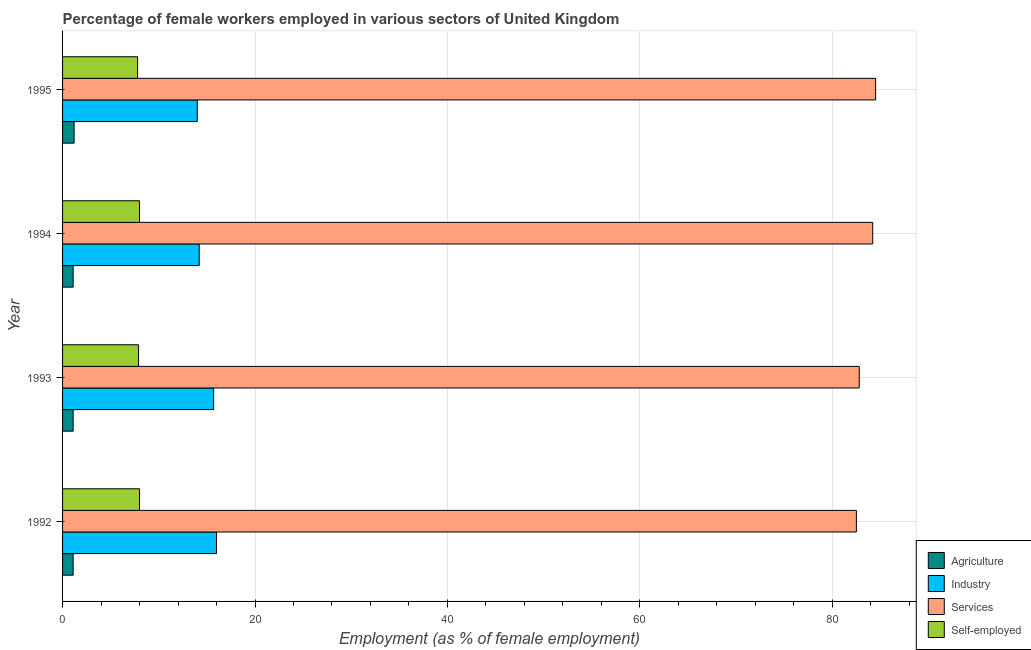How many different coloured bars are there?
Provide a succinct answer. 4. How many bars are there on the 1st tick from the bottom?
Make the answer very short. 4. What is the label of the 1st group of bars from the top?
Keep it short and to the point. 1995. In how many cases, is the number of bars for a given year not equal to the number of legend labels?
Keep it short and to the point. 0. What is the percentage of female workers in agriculture in 1994?
Provide a succinct answer. 1.1. Across all years, what is the minimum percentage of self employed female workers?
Offer a very short reply. 7.8. In which year was the percentage of female workers in services maximum?
Provide a succinct answer. 1995. In which year was the percentage of female workers in industry minimum?
Your answer should be very brief. 1995. What is the total percentage of female workers in services in the graph?
Give a very brief answer. 334. What is the difference between the percentage of female workers in services in 1993 and that in 1994?
Provide a short and direct response. -1.4. What is the difference between the percentage of female workers in agriculture in 1992 and the percentage of self employed female workers in 1995?
Provide a succinct answer. -6.7. What is the average percentage of female workers in industry per year?
Offer a very short reply. 14.97. In the year 1994, what is the difference between the percentage of female workers in industry and percentage of self employed female workers?
Offer a terse response. 6.2. In how many years, is the percentage of female workers in services greater than 24 %?
Your answer should be very brief. 4. Is the percentage of self employed female workers in 1993 less than that in 1995?
Provide a succinct answer. No. What is the difference between the highest and the second highest percentage of female workers in industry?
Make the answer very short. 0.3. What is the difference between the highest and the lowest percentage of self employed female workers?
Your answer should be compact. 0.2. In how many years, is the percentage of female workers in services greater than the average percentage of female workers in services taken over all years?
Your response must be concise. 2. Is it the case that in every year, the sum of the percentage of female workers in services and percentage of female workers in industry is greater than the sum of percentage of self employed female workers and percentage of female workers in agriculture?
Give a very brief answer. Yes. What does the 1st bar from the top in 1993 represents?
Ensure brevity in your answer.  Self-employed. What does the 4th bar from the bottom in 1993 represents?
Offer a very short reply. Self-employed. How many bars are there?
Provide a short and direct response. 16. Are all the bars in the graph horizontal?
Make the answer very short. Yes. How many legend labels are there?
Keep it short and to the point. 4. What is the title of the graph?
Keep it short and to the point. Percentage of female workers employed in various sectors of United Kingdom. Does "Trade" appear as one of the legend labels in the graph?
Offer a very short reply. No. What is the label or title of the X-axis?
Offer a very short reply. Employment (as % of female employment). What is the Employment (as % of female employment) of Agriculture in 1992?
Your response must be concise. 1.1. What is the Employment (as % of female employment) in Services in 1992?
Give a very brief answer. 82.5. What is the Employment (as % of female employment) in Self-employed in 1992?
Give a very brief answer. 8. What is the Employment (as % of female employment) in Agriculture in 1993?
Keep it short and to the point. 1.1. What is the Employment (as % of female employment) of Industry in 1993?
Offer a very short reply. 15.7. What is the Employment (as % of female employment) in Services in 1993?
Offer a terse response. 82.8. What is the Employment (as % of female employment) in Self-employed in 1993?
Make the answer very short. 7.9. What is the Employment (as % of female employment) in Agriculture in 1994?
Offer a very short reply. 1.1. What is the Employment (as % of female employment) in Industry in 1994?
Keep it short and to the point. 14.2. What is the Employment (as % of female employment) of Services in 1994?
Provide a short and direct response. 84.2. What is the Employment (as % of female employment) in Agriculture in 1995?
Your answer should be compact. 1.2. What is the Employment (as % of female employment) in Industry in 1995?
Your response must be concise. 14. What is the Employment (as % of female employment) of Services in 1995?
Give a very brief answer. 84.5. What is the Employment (as % of female employment) of Self-employed in 1995?
Offer a very short reply. 7.8. Across all years, what is the maximum Employment (as % of female employment) in Agriculture?
Your response must be concise. 1.2. Across all years, what is the maximum Employment (as % of female employment) in Industry?
Give a very brief answer. 16. Across all years, what is the maximum Employment (as % of female employment) of Services?
Provide a short and direct response. 84.5. Across all years, what is the maximum Employment (as % of female employment) in Self-employed?
Ensure brevity in your answer.  8. Across all years, what is the minimum Employment (as % of female employment) of Agriculture?
Ensure brevity in your answer.  1.1. Across all years, what is the minimum Employment (as % of female employment) of Industry?
Ensure brevity in your answer.  14. Across all years, what is the minimum Employment (as % of female employment) of Services?
Keep it short and to the point. 82.5. Across all years, what is the minimum Employment (as % of female employment) in Self-employed?
Offer a very short reply. 7.8. What is the total Employment (as % of female employment) of Agriculture in the graph?
Your answer should be compact. 4.5. What is the total Employment (as % of female employment) in Industry in the graph?
Make the answer very short. 59.9. What is the total Employment (as % of female employment) of Services in the graph?
Offer a very short reply. 334. What is the total Employment (as % of female employment) in Self-employed in the graph?
Make the answer very short. 31.7. What is the difference between the Employment (as % of female employment) in Agriculture in 1992 and that in 1994?
Keep it short and to the point. 0. What is the difference between the Employment (as % of female employment) of Industry in 1992 and that in 1994?
Offer a terse response. 1.8. What is the difference between the Employment (as % of female employment) of Services in 1992 and that in 1994?
Make the answer very short. -1.7. What is the difference between the Employment (as % of female employment) of Self-employed in 1992 and that in 1994?
Provide a succinct answer. 0. What is the difference between the Employment (as % of female employment) of Industry in 1992 and that in 1995?
Your answer should be very brief. 2. What is the difference between the Employment (as % of female employment) in Services in 1992 and that in 1995?
Your answer should be very brief. -2. What is the difference between the Employment (as % of female employment) in Agriculture in 1993 and that in 1994?
Your answer should be compact. 0. What is the difference between the Employment (as % of female employment) in Industry in 1993 and that in 1994?
Your answer should be very brief. 1.5. What is the difference between the Employment (as % of female employment) in Self-employed in 1993 and that in 1994?
Make the answer very short. -0.1. What is the difference between the Employment (as % of female employment) in Agriculture in 1993 and that in 1995?
Provide a succinct answer. -0.1. What is the difference between the Employment (as % of female employment) of Self-employed in 1993 and that in 1995?
Keep it short and to the point. 0.1. What is the difference between the Employment (as % of female employment) in Agriculture in 1992 and the Employment (as % of female employment) in Industry in 1993?
Ensure brevity in your answer.  -14.6. What is the difference between the Employment (as % of female employment) in Agriculture in 1992 and the Employment (as % of female employment) in Services in 1993?
Provide a short and direct response. -81.7. What is the difference between the Employment (as % of female employment) in Industry in 1992 and the Employment (as % of female employment) in Services in 1993?
Provide a short and direct response. -66.8. What is the difference between the Employment (as % of female employment) in Services in 1992 and the Employment (as % of female employment) in Self-employed in 1993?
Give a very brief answer. 74.6. What is the difference between the Employment (as % of female employment) of Agriculture in 1992 and the Employment (as % of female employment) of Industry in 1994?
Offer a terse response. -13.1. What is the difference between the Employment (as % of female employment) in Agriculture in 1992 and the Employment (as % of female employment) in Services in 1994?
Make the answer very short. -83.1. What is the difference between the Employment (as % of female employment) in Industry in 1992 and the Employment (as % of female employment) in Services in 1994?
Offer a very short reply. -68.2. What is the difference between the Employment (as % of female employment) of Services in 1992 and the Employment (as % of female employment) of Self-employed in 1994?
Your response must be concise. 74.5. What is the difference between the Employment (as % of female employment) of Agriculture in 1992 and the Employment (as % of female employment) of Services in 1995?
Provide a succinct answer. -83.4. What is the difference between the Employment (as % of female employment) of Agriculture in 1992 and the Employment (as % of female employment) of Self-employed in 1995?
Offer a terse response. -6.7. What is the difference between the Employment (as % of female employment) of Industry in 1992 and the Employment (as % of female employment) of Services in 1995?
Your answer should be very brief. -68.5. What is the difference between the Employment (as % of female employment) of Services in 1992 and the Employment (as % of female employment) of Self-employed in 1995?
Your answer should be very brief. 74.7. What is the difference between the Employment (as % of female employment) in Agriculture in 1993 and the Employment (as % of female employment) in Services in 1994?
Keep it short and to the point. -83.1. What is the difference between the Employment (as % of female employment) in Industry in 1993 and the Employment (as % of female employment) in Services in 1994?
Your response must be concise. -68.5. What is the difference between the Employment (as % of female employment) in Industry in 1993 and the Employment (as % of female employment) in Self-employed in 1994?
Provide a short and direct response. 7.7. What is the difference between the Employment (as % of female employment) of Services in 1993 and the Employment (as % of female employment) of Self-employed in 1994?
Your answer should be compact. 74.8. What is the difference between the Employment (as % of female employment) in Agriculture in 1993 and the Employment (as % of female employment) in Industry in 1995?
Give a very brief answer. -12.9. What is the difference between the Employment (as % of female employment) in Agriculture in 1993 and the Employment (as % of female employment) in Services in 1995?
Offer a very short reply. -83.4. What is the difference between the Employment (as % of female employment) in Industry in 1993 and the Employment (as % of female employment) in Services in 1995?
Keep it short and to the point. -68.8. What is the difference between the Employment (as % of female employment) in Services in 1993 and the Employment (as % of female employment) in Self-employed in 1995?
Offer a terse response. 75. What is the difference between the Employment (as % of female employment) of Agriculture in 1994 and the Employment (as % of female employment) of Industry in 1995?
Provide a succinct answer. -12.9. What is the difference between the Employment (as % of female employment) of Agriculture in 1994 and the Employment (as % of female employment) of Services in 1995?
Your answer should be very brief. -83.4. What is the difference between the Employment (as % of female employment) in Industry in 1994 and the Employment (as % of female employment) in Services in 1995?
Offer a terse response. -70.3. What is the difference between the Employment (as % of female employment) in Services in 1994 and the Employment (as % of female employment) in Self-employed in 1995?
Keep it short and to the point. 76.4. What is the average Employment (as % of female employment) in Industry per year?
Your answer should be compact. 14.97. What is the average Employment (as % of female employment) of Services per year?
Your answer should be very brief. 83.5. What is the average Employment (as % of female employment) in Self-employed per year?
Provide a short and direct response. 7.92. In the year 1992, what is the difference between the Employment (as % of female employment) in Agriculture and Employment (as % of female employment) in Industry?
Offer a terse response. -14.9. In the year 1992, what is the difference between the Employment (as % of female employment) in Agriculture and Employment (as % of female employment) in Services?
Offer a terse response. -81.4. In the year 1992, what is the difference between the Employment (as % of female employment) of Industry and Employment (as % of female employment) of Services?
Offer a very short reply. -66.5. In the year 1992, what is the difference between the Employment (as % of female employment) of Services and Employment (as % of female employment) of Self-employed?
Keep it short and to the point. 74.5. In the year 1993, what is the difference between the Employment (as % of female employment) of Agriculture and Employment (as % of female employment) of Industry?
Offer a very short reply. -14.6. In the year 1993, what is the difference between the Employment (as % of female employment) in Agriculture and Employment (as % of female employment) in Services?
Ensure brevity in your answer.  -81.7. In the year 1993, what is the difference between the Employment (as % of female employment) of Industry and Employment (as % of female employment) of Services?
Offer a terse response. -67.1. In the year 1993, what is the difference between the Employment (as % of female employment) in Industry and Employment (as % of female employment) in Self-employed?
Offer a terse response. 7.8. In the year 1993, what is the difference between the Employment (as % of female employment) in Services and Employment (as % of female employment) in Self-employed?
Offer a terse response. 74.9. In the year 1994, what is the difference between the Employment (as % of female employment) in Agriculture and Employment (as % of female employment) in Services?
Give a very brief answer. -83.1. In the year 1994, what is the difference between the Employment (as % of female employment) of Industry and Employment (as % of female employment) of Services?
Provide a succinct answer. -70. In the year 1994, what is the difference between the Employment (as % of female employment) of Services and Employment (as % of female employment) of Self-employed?
Keep it short and to the point. 76.2. In the year 1995, what is the difference between the Employment (as % of female employment) in Agriculture and Employment (as % of female employment) in Industry?
Your answer should be very brief. -12.8. In the year 1995, what is the difference between the Employment (as % of female employment) of Agriculture and Employment (as % of female employment) of Services?
Your answer should be compact. -83.3. In the year 1995, what is the difference between the Employment (as % of female employment) in Industry and Employment (as % of female employment) in Services?
Make the answer very short. -70.5. In the year 1995, what is the difference between the Employment (as % of female employment) of Services and Employment (as % of female employment) of Self-employed?
Make the answer very short. 76.7. What is the ratio of the Employment (as % of female employment) of Agriculture in 1992 to that in 1993?
Your answer should be compact. 1. What is the ratio of the Employment (as % of female employment) in Industry in 1992 to that in 1993?
Make the answer very short. 1.02. What is the ratio of the Employment (as % of female employment) of Services in 1992 to that in 1993?
Make the answer very short. 1. What is the ratio of the Employment (as % of female employment) of Self-employed in 1992 to that in 1993?
Provide a succinct answer. 1.01. What is the ratio of the Employment (as % of female employment) in Agriculture in 1992 to that in 1994?
Make the answer very short. 1. What is the ratio of the Employment (as % of female employment) in Industry in 1992 to that in 1994?
Ensure brevity in your answer.  1.13. What is the ratio of the Employment (as % of female employment) of Services in 1992 to that in 1994?
Keep it short and to the point. 0.98. What is the ratio of the Employment (as % of female employment) in Services in 1992 to that in 1995?
Your answer should be compact. 0.98. What is the ratio of the Employment (as % of female employment) in Self-employed in 1992 to that in 1995?
Make the answer very short. 1.03. What is the ratio of the Employment (as % of female employment) of Agriculture in 1993 to that in 1994?
Make the answer very short. 1. What is the ratio of the Employment (as % of female employment) of Industry in 1993 to that in 1994?
Your answer should be compact. 1.11. What is the ratio of the Employment (as % of female employment) in Services in 1993 to that in 1994?
Keep it short and to the point. 0.98. What is the ratio of the Employment (as % of female employment) of Self-employed in 1993 to that in 1994?
Your response must be concise. 0.99. What is the ratio of the Employment (as % of female employment) in Agriculture in 1993 to that in 1995?
Your response must be concise. 0.92. What is the ratio of the Employment (as % of female employment) of Industry in 1993 to that in 1995?
Provide a short and direct response. 1.12. What is the ratio of the Employment (as % of female employment) in Services in 1993 to that in 1995?
Provide a succinct answer. 0.98. What is the ratio of the Employment (as % of female employment) of Self-employed in 1993 to that in 1995?
Your answer should be compact. 1.01. What is the ratio of the Employment (as % of female employment) in Agriculture in 1994 to that in 1995?
Keep it short and to the point. 0.92. What is the ratio of the Employment (as % of female employment) of Industry in 1994 to that in 1995?
Ensure brevity in your answer.  1.01. What is the ratio of the Employment (as % of female employment) in Self-employed in 1994 to that in 1995?
Offer a very short reply. 1.03. What is the difference between the highest and the lowest Employment (as % of female employment) in Services?
Offer a terse response. 2. What is the difference between the highest and the lowest Employment (as % of female employment) of Self-employed?
Offer a terse response. 0.2. 